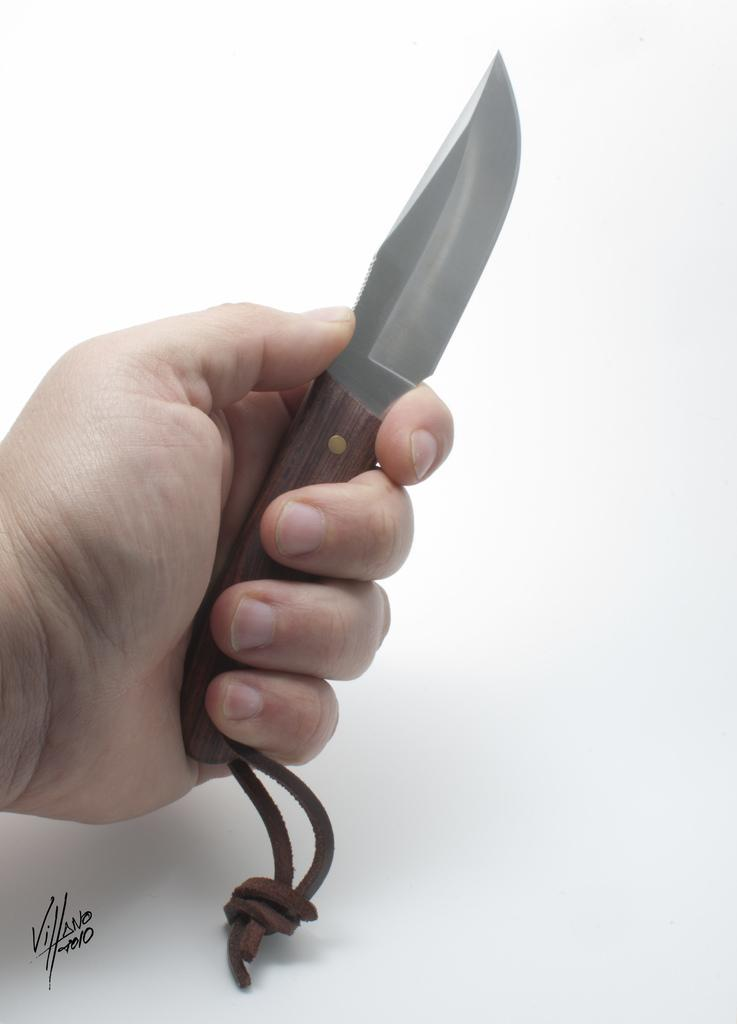What object is being held by someone in the image? There is a knife in the image, and it is being held by someone. Can you describe the knife in the image? The knife is being held by someone, but its specific appearance or size cannot be determined from the provided facts. What additional detail can be observed at the bottom of the image? There is a watermark at the bottom of the image. What type of underwear is visible in the image? There is no underwear present in the image. Can you describe the faucet in the image? There is no faucet present in the image. How many flies can be seen in the image? There are no flies present in the image. 